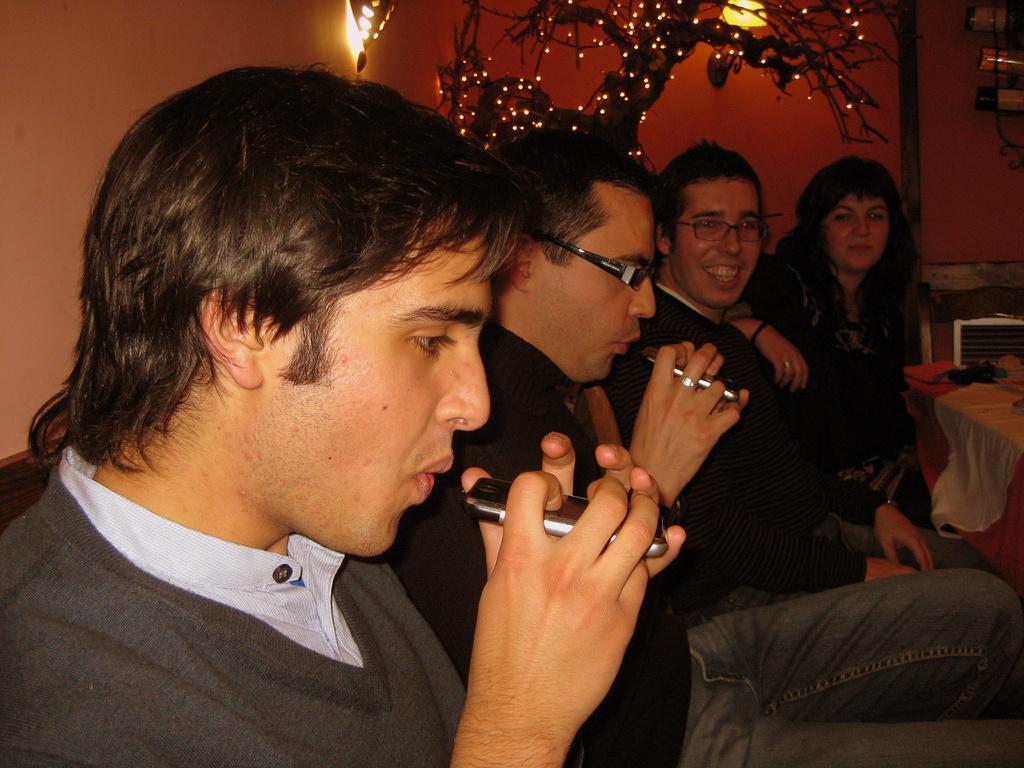Describe this image in one or two sentences. In this picture a group of people sitting one of them is smiling and in the backdrop there is a plant and some lights. 